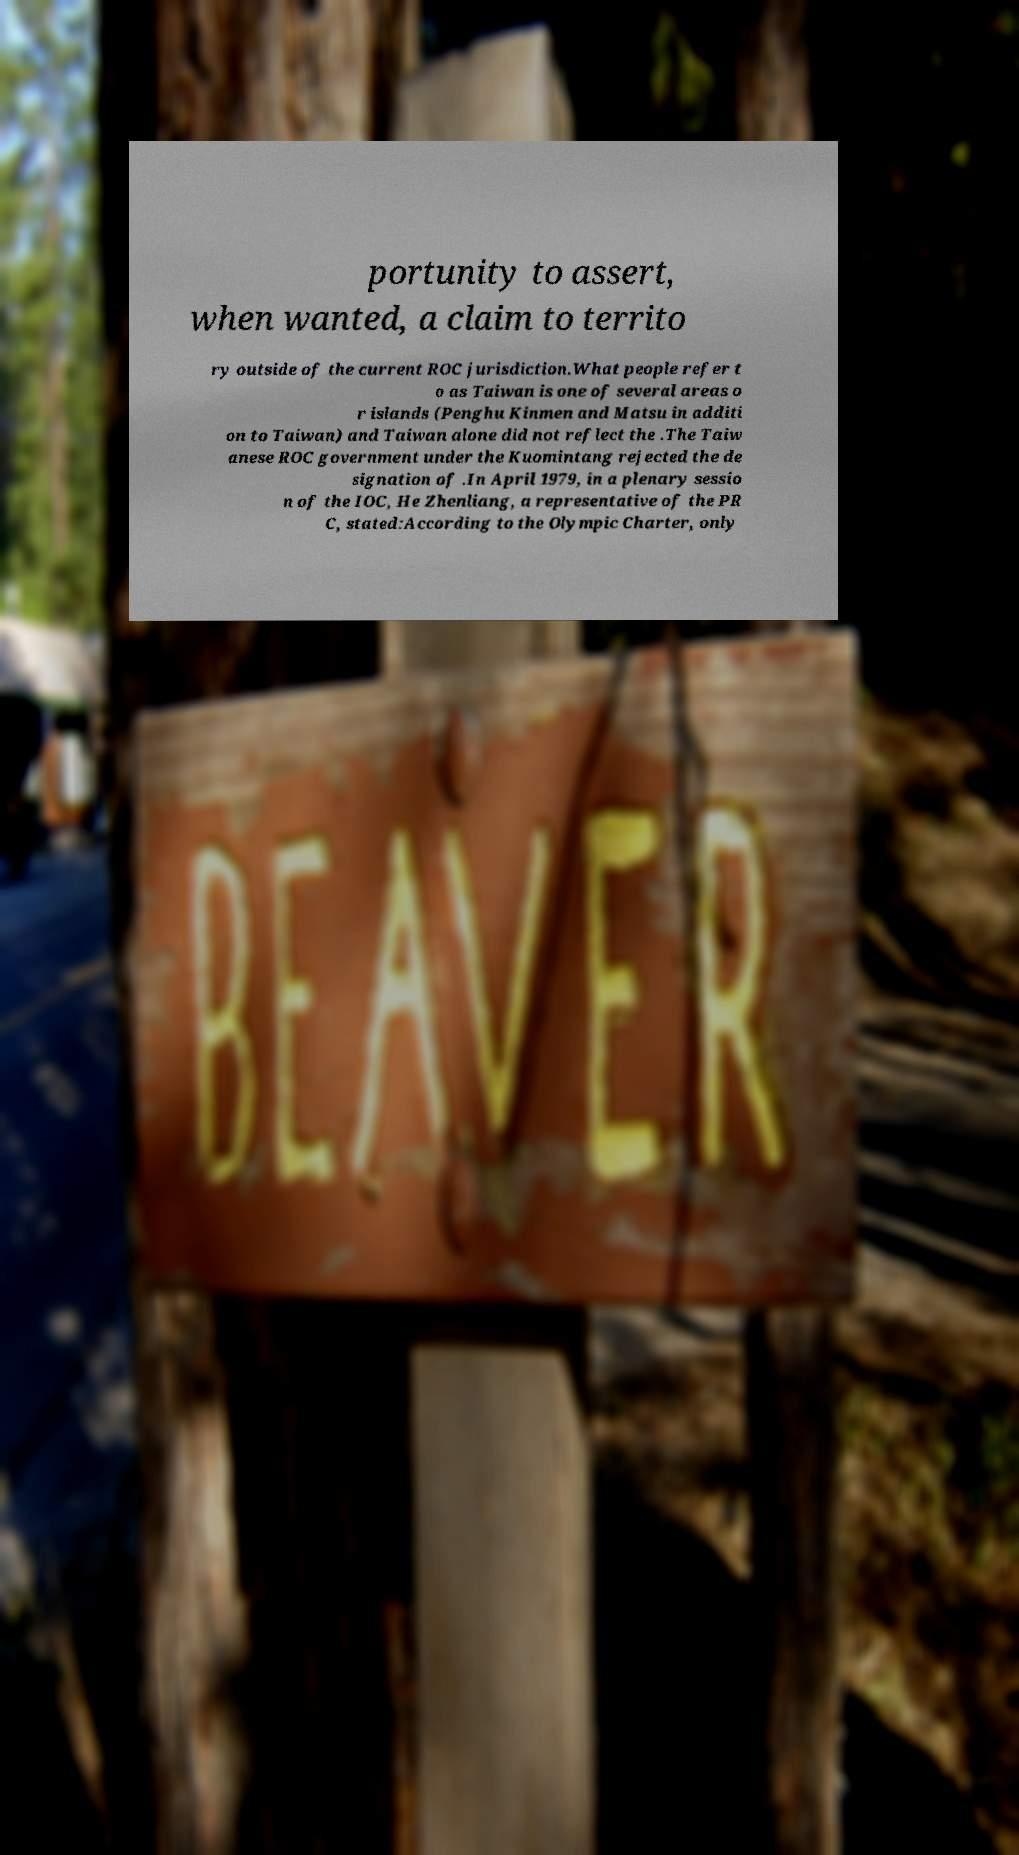Please read and relay the text visible in this image. What does it say? portunity to assert, when wanted, a claim to territo ry outside of the current ROC jurisdiction.What people refer t o as Taiwan is one of several areas o r islands (Penghu Kinmen and Matsu in additi on to Taiwan) and Taiwan alone did not reflect the .The Taiw anese ROC government under the Kuomintang rejected the de signation of .In April 1979, in a plenary sessio n of the IOC, He Zhenliang, a representative of the PR C, stated:According to the Olympic Charter, only 